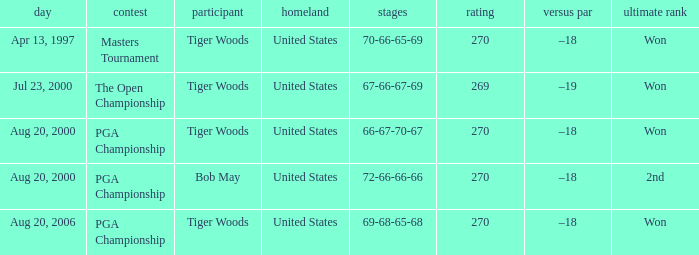What country hosts the tournament the open championship? United States. 